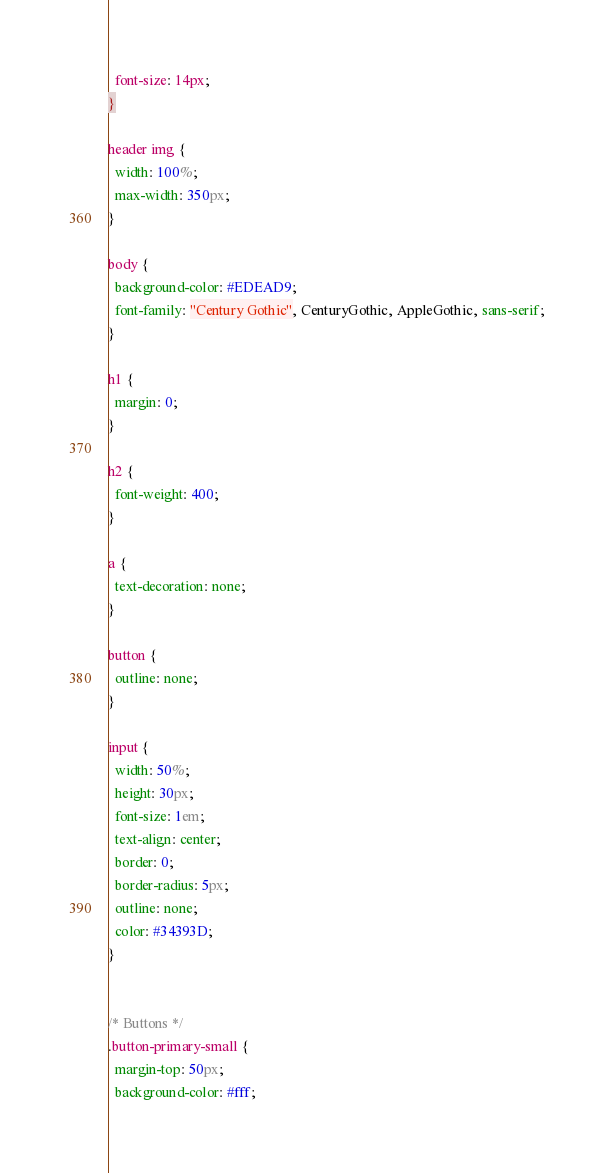Convert code to text. <code><loc_0><loc_0><loc_500><loc_500><_CSS_>  font-size: 14px;
}

header img {
  width: 100%;
  max-width: 350px;
}

body {
  background-color: #EDEAD9;
  font-family: "Century Gothic", CenturyGothic, AppleGothic, sans-serif;
}

h1 {
  margin: 0;
}

h2 {
  font-weight: 400;
}

a {
  text-decoration: none;
}

button {
  outline: none;
}

input {
  width: 50%;
  height: 30px;
  font-size: 1em;
  text-align: center;
  border: 0;
  border-radius: 5px;
  outline: none;
  color: #34393D;
}


/* Buttons */
.button-primary-small {
  margin-top: 50px;
  background-color: #fff;</code> 